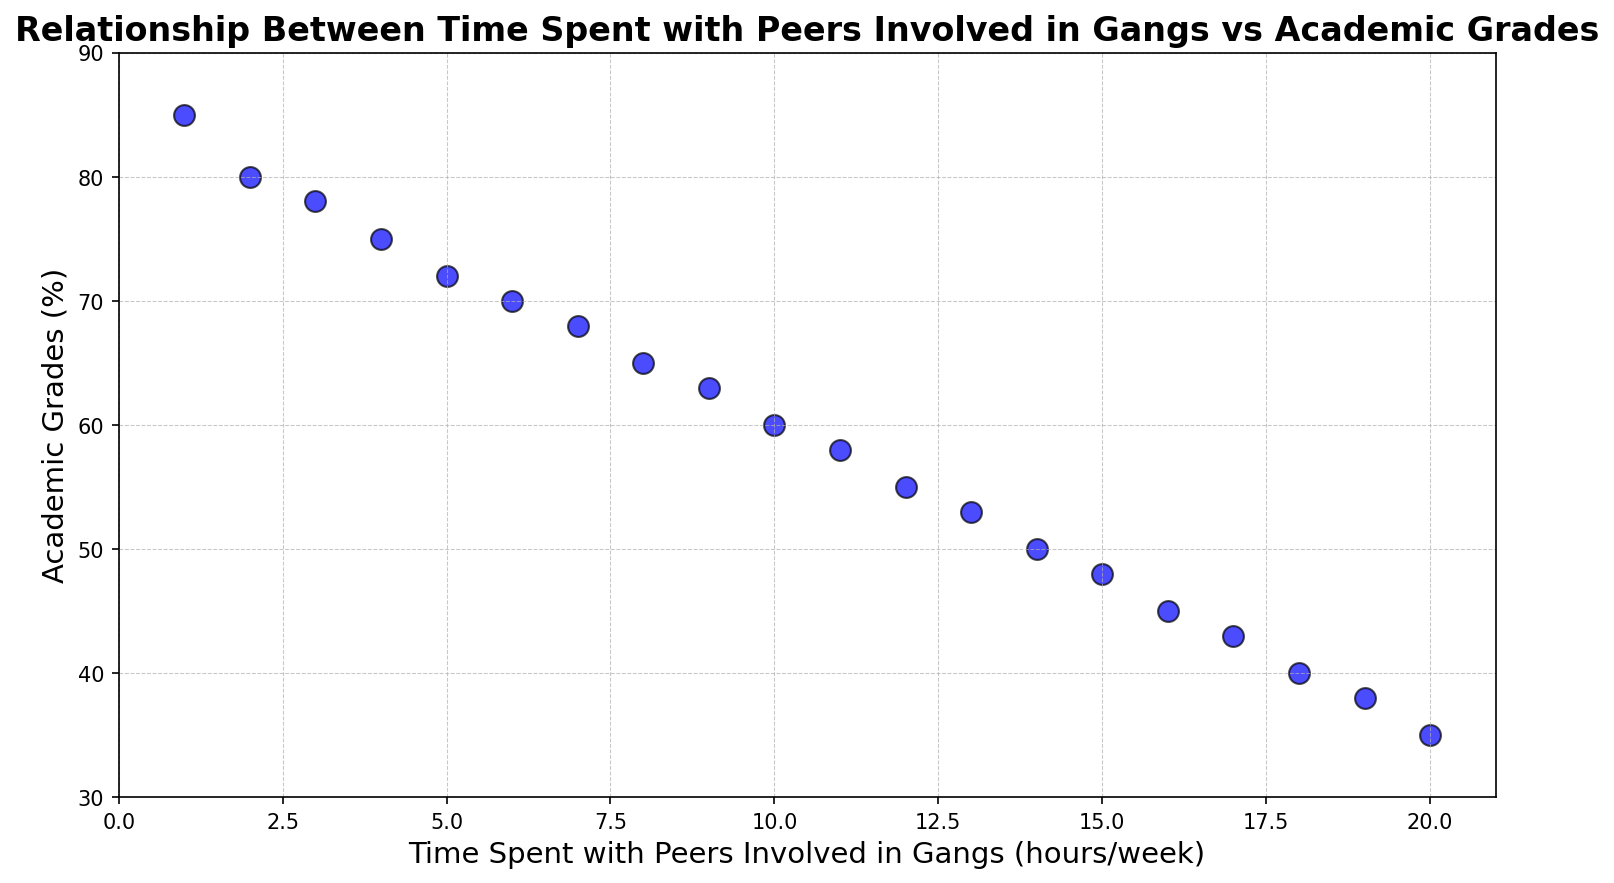What's the average academic grade when the time spent with peers involved in gangs is between 5 and 10 hours/week? First, identify the academic grades corresponding to the time spent with peers involved in gangs between 5 and 10 hours/week. These grades are 72, 70, 68, 65, 63, and 60. Sum them up: 72 + 70 + 68 + 65 + 63 + 60 = 398. Divide by the number of data points: 398 / 6 = 66.33
Answer: 66.33 How do academic grades change as time spent with peers involved in gangs increases from 1 to 20 hours/week? The grades decrease steadily as time spent with peers involved in gangs increases. This can be observed by noting that as the time goes from 1 hour/week (85%) to 20 hours/week (35%), the grades decrease in a relatively linear manner.
Answer: Decrease steadily Is there a threshold of time spent with peers involved in gangs after which academic grades fall below 50%? The first instance where academic grades fall below 50% occurs when the time spent with peers involved in gangs reaches 14 hours/week with the grade being 50%.
Answer: 14 hours/week What is the difference in academic grades between 1 hour/week and 20 hours/week of time spent with peers involved in gangs? The academic grade at 1 hour/week is 85%, and at 20 hours/week it is 35%. The difference is calculated by subtracting: 85 - 35 = 50.
Answer: 50 Between which time intervals is the most significant drop in academic grades observed? By examining the scatter plot, the most significant drop in academic grades appears between 1 to 5 hours/week, where grades drop from 85% to 72%.
Answer: 1 to 5 hours/week Do any points show an increase in academic grades as time spent with peers involved in gangs increases? On close inspection of the scatter plot, no data points show an increase in academic grades; the trend consistently shows a decrease.
Answer: No What is the average grade for all the data points on the plot? To calculate the average grade, sum all the grades: 85 + 80 + 78 + 75 + 72 + 70 + 68 + 65 + 63 + 60 + 58 + 55 + 53 + 50 + 48 + 45 + 43 + 40 + 38 + 35 = 1130. Divide by the number of data points: 1130 / 20 = 56.5
Answer: 56.5 Is the decrease in academic grades consistent over the intervals, or does it vary? Evaluating the scatter plot, the decrease in academic grades appears to be relatively consistent, with no large fluctuations, as time spent with peers involved in gangs increases.
Answer: Consistent Which data point has the lowest academic grade, and what is the corresponding time spent with peers involved in gangs? The lowest academic grade is 35%, which corresponds to 20 hours/week spent with peers involved in gangs.
Answer: 20 hours/week How many hours of time spent with peers involved in gangs corresponds to an academic grade of around 70%? Observing the scatter plot, an academic grade of around 70% corresponds to approximately 6 hours/week spent with peers involved in gangs.
Answer: 6 hours/week 